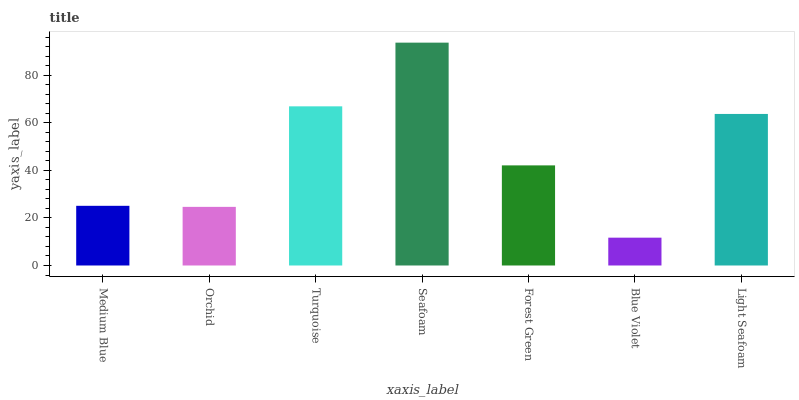Is Blue Violet the minimum?
Answer yes or no. Yes. Is Seafoam the maximum?
Answer yes or no. Yes. Is Orchid the minimum?
Answer yes or no. No. Is Orchid the maximum?
Answer yes or no. No. Is Medium Blue greater than Orchid?
Answer yes or no. Yes. Is Orchid less than Medium Blue?
Answer yes or no. Yes. Is Orchid greater than Medium Blue?
Answer yes or no. No. Is Medium Blue less than Orchid?
Answer yes or no. No. Is Forest Green the high median?
Answer yes or no. Yes. Is Forest Green the low median?
Answer yes or no. Yes. Is Medium Blue the high median?
Answer yes or no. No. Is Medium Blue the low median?
Answer yes or no. No. 